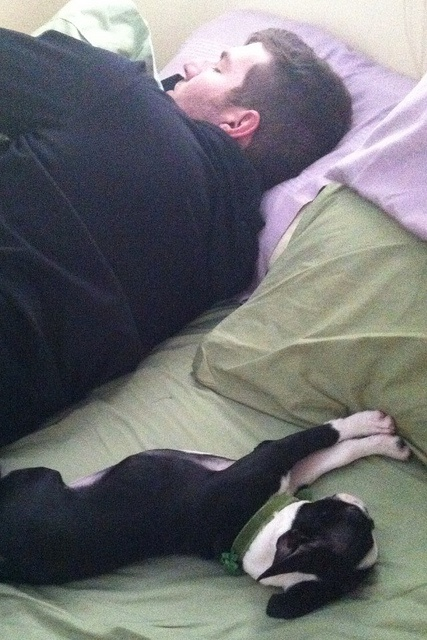Describe the objects in this image and their specific colors. I can see bed in beige, darkgray, gray, and lavender tones, people in beige, black, and gray tones, and dog in beige, black, gray, darkgray, and lightgray tones in this image. 